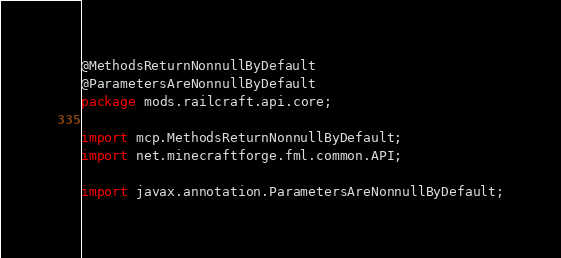<code> <loc_0><loc_0><loc_500><loc_500><_Java_>@MethodsReturnNonnullByDefault
@ParametersAreNonnullByDefault
package mods.railcraft.api.core;

import mcp.MethodsReturnNonnullByDefault;
import net.minecraftforge.fml.common.API;

import javax.annotation.ParametersAreNonnullByDefault;
</code> 